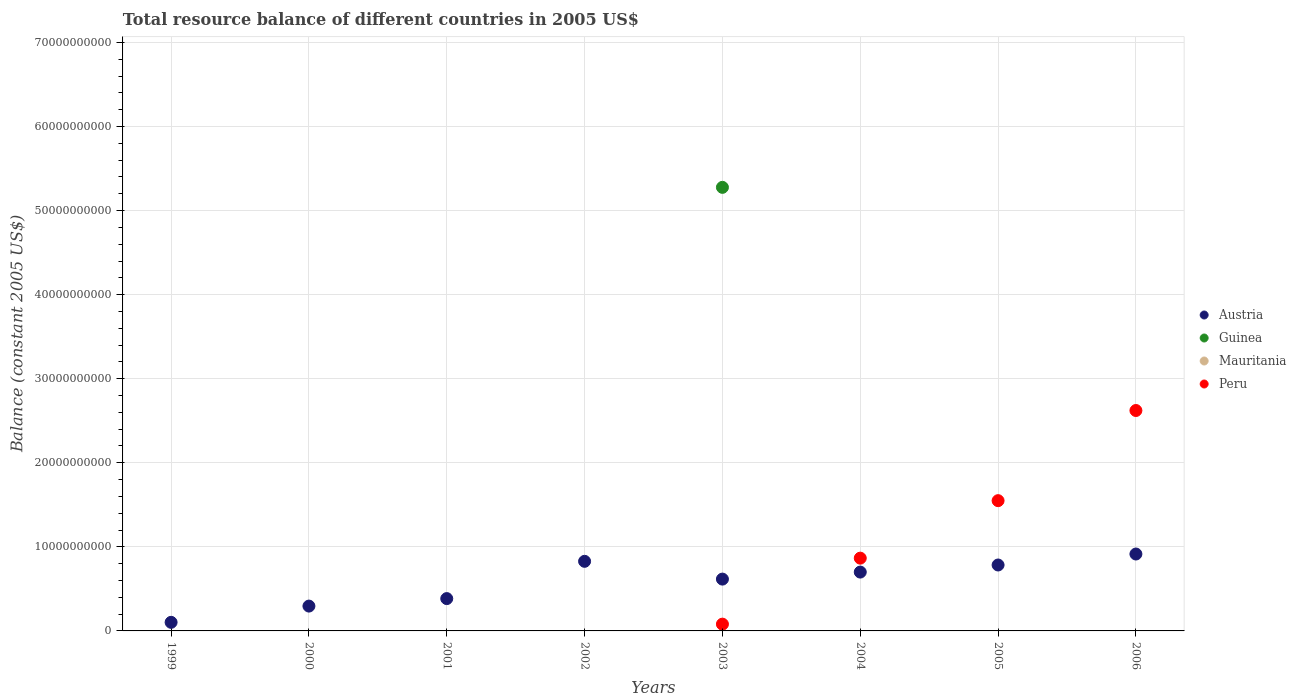What is the total resource balance in Guinea in 2001?
Offer a terse response. 0. Across all years, what is the maximum total resource balance in Austria?
Provide a succinct answer. 9.15e+09. Across all years, what is the minimum total resource balance in Peru?
Provide a succinct answer. 0. In which year was the total resource balance in Austria maximum?
Offer a terse response. 2006. What is the total total resource balance in Guinea in the graph?
Ensure brevity in your answer.  5.28e+1. What is the difference between the total resource balance in Peru in 2003 and that in 2006?
Provide a short and direct response. -2.54e+1. What is the difference between the total resource balance in Mauritania in 2003 and the total resource balance in Peru in 2001?
Your response must be concise. 0. What is the average total resource balance in Mauritania per year?
Keep it short and to the point. 0. In how many years, is the total resource balance in Mauritania greater than 34000000000 US$?
Provide a short and direct response. 0. What is the ratio of the total resource balance in Austria in 2001 to that in 2006?
Ensure brevity in your answer.  0.42. Is the total resource balance in Austria in 2001 less than that in 2002?
Keep it short and to the point. Yes. What is the difference between the highest and the second highest total resource balance in Austria?
Your response must be concise. 8.69e+08. What is the difference between the highest and the lowest total resource balance in Guinea?
Ensure brevity in your answer.  5.28e+1. Is it the case that in every year, the sum of the total resource balance in Mauritania and total resource balance in Peru  is greater than the sum of total resource balance in Guinea and total resource balance in Austria?
Provide a succinct answer. No. Is it the case that in every year, the sum of the total resource balance in Mauritania and total resource balance in Guinea  is greater than the total resource balance in Peru?
Offer a very short reply. No. Does the total resource balance in Guinea monotonically increase over the years?
Give a very brief answer. No. Is the total resource balance in Mauritania strictly less than the total resource balance in Austria over the years?
Keep it short and to the point. Yes. How many dotlines are there?
Provide a succinct answer. 3. What is the difference between two consecutive major ticks on the Y-axis?
Keep it short and to the point. 1.00e+1. Does the graph contain any zero values?
Give a very brief answer. Yes. Does the graph contain grids?
Keep it short and to the point. Yes. How many legend labels are there?
Keep it short and to the point. 4. How are the legend labels stacked?
Make the answer very short. Vertical. What is the title of the graph?
Keep it short and to the point. Total resource balance of different countries in 2005 US$. Does "Small states" appear as one of the legend labels in the graph?
Your response must be concise. No. What is the label or title of the X-axis?
Your response must be concise. Years. What is the label or title of the Y-axis?
Ensure brevity in your answer.  Balance (constant 2005 US$). What is the Balance (constant 2005 US$) in Austria in 1999?
Offer a terse response. 1.02e+09. What is the Balance (constant 2005 US$) in Guinea in 1999?
Give a very brief answer. 0. What is the Balance (constant 2005 US$) in Mauritania in 1999?
Your answer should be very brief. 0. What is the Balance (constant 2005 US$) of Austria in 2000?
Give a very brief answer. 2.95e+09. What is the Balance (constant 2005 US$) in Guinea in 2000?
Keep it short and to the point. 0. What is the Balance (constant 2005 US$) of Mauritania in 2000?
Make the answer very short. 0. What is the Balance (constant 2005 US$) of Peru in 2000?
Provide a succinct answer. 0. What is the Balance (constant 2005 US$) of Austria in 2001?
Your response must be concise. 3.85e+09. What is the Balance (constant 2005 US$) in Peru in 2001?
Provide a succinct answer. 0. What is the Balance (constant 2005 US$) in Austria in 2002?
Your response must be concise. 8.28e+09. What is the Balance (constant 2005 US$) in Mauritania in 2002?
Your answer should be very brief. 0. What is the Balance (constant 2005 US$) of Peru in 2002?
Give a very brief answer. 0. What is the Balance (constant 2005 US$) in Austria in 2003?
Provide a short and direct response. 6.16e+09. What is the Balance (constant 2005 US$) in Guinea in 2003?
Your response must be concise. 5.28e+1. What is the Balance (constant 2005 US$) of Mauritania in 2003?
Provide a short and direct response. 0. What is the Balance (constant 2005 US$) in Peru in 2003?
Make the answer very short. 8.06e+08. What is the Balance (constant 2005 US$) in Austria in 2004?
Keep it short and to the point. 7.00e+09. What is the Balance (constant 2005 US$) in Mauritania in 2004?
Provide a succinct answer. 0. What is the Balance (constant 2005 US$) of Peru in 2004?
Offer a very short reply. 8.66e+09. What is the Balance (constant 2005 US$) in Austria in 2005?
Give a very brief answer. 7.84e+09. What is the Balance (constant 2005 US$) in Guinea in 2005?
Make the answer very short. 0. What is the Balance (constant 2005 US$) in Mauritania in 2005?
Make the answer very short. 0. What is the Balance (constant 2005 US$) of Peru in 2005?
Provide a succinct answer. 1.55e+1. What is the Balance (constant 2005 US$) of Austria in 2006?
Give a very brief answer. 9.15e+09. What is the Balance (constant 2005 US$) of Mauritania in 2006?
Give a very brief answer. 0. What is the Balance (constant 2005 US$) of Peru in 2006?
Provide a short and direct response. 2.62e+1. Across all years, what is the maximum Balance (constant 2005 US$) of Austria?
Make the answer very short. 9.15e+09. Across all years, what is the maximum Balance (constant 2005 US$) in Guinea?
Ensure brevity in your answer.  5.28e+1. Across all years, what is the maximum Balance (constant 2005 US$) of Peru?
Give a very brief answer. 2.62e+1. Across all years, what is the minimum Balance (constant 2005 US$) in Austria?
Provide a short and direct response. 1.02e+09. Across all years, what is the minimum Balance (constant 2005 US$) in Guinea?
Provide a short and direct response. 0. Across all years, what is the minimum Balance (constant 2005 US$) of Peru?
Give a very brief answer. 0. What is the total Balance (constant 2005 US$) in Austria in the graph?
Keep it short and to the point. 4.63e+1. What is the total Balance (constant 2005 US$) in Guinea in the graph?
Keep it short and to the point. 5.28e+1. What is the total Balance (constant 2005 US$) of Mauritania in the graph?
Provide a succinct answer. 0. What is the total Balance (constant 2005 US$) of Peru in the graph?
Make the answer very short. 5.12e+1. What is the difference between the Balance (constant 2005 US$) of Austria in 1999 and that in 2000?
Your answer should be compact. -1.93e+09. What is the difference between the Balance (constant 2005 US$) of Austria in 1999 and that in 2001?
Offer a terse response. -2.82e+09. What is the difference between the Balance (constant 2005 US$) in Austria in 1999 and that in 2002?
Offer a very short reply. -7.26e+09. What is the difference between the Balance (constant 2005 US$) in Austria in 1999 and that in 2003?
Keep it short and to the point. -5.14e+09. What is the difference between the Balance (constant 2005 US$) in Austria in 1999 and that in 2004?
Your answer should be very brief. -5.98e+09. What is the difference between the Balance (constant 2005 US$) in Austria in 1999 and that in 2005?
Offer a terse response. -6.82e+09. What is the difference between the Balance (constant 2005 US$) in Austria in 1999 and that in 2006?
Offer a terse response. -8.13e+09. What is the difference between the Balance (constant 2005 US$) in Austria in 2000 and that in 2001?
Keep it short and to the point. -8.91e+08. What is the difference between the Balance (constant 2005 US$) of Austria in 2000 and that in 2002?
Provide a short and direct response. -5.33e+09. What is the difference between the Balance (constant 2005 US$) in Austria in 2000 and that in 2003?
Your response must be concise. -3.21e+09. What is the difference between the Balance (constant 2005 US$) of Austria in 2000 and that in 2004?
Make the answer very short. -4.05e+09. What is the difference between the Balance (constant 2005 US$) in Austria in 2000 and that in 2005?
Provide a short and direct response. -4.89e+09. What is the difference between the Balance (constant 2005 US$) of Austria in 2000 and that in 2006?
Your response must be concise. -6.19e+09. What is the difference between the Balance (constant 2005 US$) in Austria in 2001 and that in 2002?
Give a very brief answer. -4.43e+09. What is the difference between the Balance (constant 2005 US$) in Austria in 2001 and that in 2003?
Offer a very short reply. -2.32e+09. What is the difference between the Balance (constant 2005 US$) in Austria in 2001 and that in 2004?
Your answer should be very brief. -3.15e+09. What is the difference between the Balance (constant 2005 US$) in Austria in 2001 and that in 2005?
Give a very brief answer. -4.00e+09. What is the difference between the Balance (constant 2005 US$) of Austria in 2001 and that in 2006?
Your answer should be very brief. -5.30e+09. What is the difference between the Balance (constant 2005 US$) of Austria in 2002 and that in 2003?
Provide a short and direct response. 2.11e+09. What is the difference between the Balance (constant 2005 US$) of Austria in 2002 and that in 2004?
Make the answer very short. 1.28e+09. What is the difference between the Balance (constant 2005 US$) of Austria in 2002 and that in 2005?
Your response must be concise. 4.37e+08. What is the difference between the Balance (constant 2005 US$) of Austria in 2002 and that in 2006?
Provide a short and direct response. -8.69e+08. What is the difference between the Balance (constant 2005 US$) of Austria in 2003 and that in 2004?
Offer a very short reply. -8.35e+08. What is the difference between the Balance (constant 2005 US$) of Peru in 2003 and that in 2004?
Give a very brief answer. -7.85e+09. What is the difference between the Balance (constant 2005 US$) in Austria in 2003 and that in 2005?
Keep it short and to the point. -1.68e+09. What is the difference between the Balance (constant 2005 US$) of Peru in 2003 and that in 2005?
Make the answer very short. -1.47e+1. What is the difference between the Balance (constant 2005 US$) of Austria in 2003 and that in 2006?
Offer a terse response. -2.98e+09. What is the difference between the Balance (constant 2005 US$) of Peru in 2003 and that in 2006?
Keep it short and to the point. -2.54e+1. What is the difference between the Balance (constant 2005 US$) of Austria in 2004 and that in 2005?
Your answer should be compact. -8.43e+08. What is the difference between the Balance (constant 2005 US$) of Peru in 2004 and that in 2005?
Ensure brevity in your answer.  -6.84e+09. What is the difference between the Balance (constant 2005 US$) of Austria in 2004 and that in 2006?
Offer a very short reply. -2.15e+09. What is the difference between the Balance (constant 2005 US$) in Peru in 2004 and that in 2006?
Your response must be concise. -1.76e+1. What is the difference between the Balance (constant 2005 US$) in Austria in 2005 and that in 2006?
Your answer should be compact. -1.31e+09. What is the difference between the Balance (constant 2005 US$) in Peru in 2005 and that in 2006?
Provide a succinct answer. -1.07e+1. What is the difference between the Balance (constant 2005 US$) of Austria in 1999 and the Balance (constant 2005 US$) of Guinea in 2003?
Provide a succinct answer. -5.17e+1. What is the difference between the Balance (constant 2005 US$) in Austria in 1999 and the Balance (constant 2005 US$) in Peru in 2003?
Keep it short and to the point. 2.15e+08. What is the difference between the Balance (constant 2005 US$) in Austria in 1999 and the Balance (constant 2005 US$) in Peru in 2004?
Provide a short and direct response. -7.64e+09. What is the difference between the Balance (constant 2005 US$) of Austria in 1999 and the Balance (constant 2005 US$) of Peru in 2005?
Offer a very short reply. -1.45e+1. What is the difference between the Balance (constant 2005 US$) of Austria in 1999 and the Balance (constant 2005 US$) of Peru in 2006?
Provide a short and direct response. -2.52e+1. What is the difference between the Balance (constant 2005 US$) in Austria in 2000 and the Balance (constant 2005 US$) in Guinea in 2003?
Keep it short and to the point. -4.98e+1. What is the difference between the Balance (constant 2005 US$) of Austria in 2000 and the Balance (constant 2005 US$) of Peru in 2003?
Offer a very short reply. 2.15e+09. What is the difference between the Balance (constant 2005 US$) of Austria in 2000 and the Balance (constant 2005 US$) of Peru in 2004?
Give a very brief answer. -5.70e+09. What is the difference between the Balance (constant 2005 US$) in Austria in 2000 and the Balance (constant 2005 US$) in Peru in 2005?
Ensure brevity in your answer.  -1.25e+1. What is the difference between the Balance (constant 2005 US$) in Austria in 2000 and the Balance (constant 2005 US$) in Peru in 2006?
Keep it short and to the point. -2.33e+1. What is the difference between the Balance (constant 2005 US$) of Austria in 2001 and the Balance (constant 2005 US$) of Guinea in 2003?
Your answer should be very brief. -4.89e+1. What is the difference between the Balance (constant 2005 US$) in Austria in 2001 and the Balance (constant 2005 US$) in Peru in 2003?
Your response must be concise. 3.04e+09. What is the difference between the Balance (constant 2005 US$) of Austria in 2001 and the Balance (constant 2005 US$) of Peru in 2004?
Provide a succinct answer. -4.81e+09. What is the difference between the Balance (constant 2005 US$) of Austria in 2001 and the Balance (constant 2005 US$) of Peru in 2005?
Ensure brevity in your answer.  -1.17e+1. What is the difference between the Balance (constant 2005 US$) in Austria in 2001 and the Balance (constant 2005 US$) in Peru in 2006?
Ensure brevity in your answer.  -2.24e+1. What is the difference between the Balance (constant 2005 US$) in Austria in 2002 and the Balance (constant 2005 US$) in Guinea in 2003?
Make the answer very short. -4.45e+1. What is the difference between the Balance (constant 2005 US$) in Austria in 2002 and the Balance (constant 2005 US$) in Peru in 2003?
Keep it short and to the point. 7.47e+09. What is the difference between the Balance (constant 2005 US$) of Austria in 2002 and the Balance (constant 2005 US$) of Peru in 2004?
Give a very brief answer. -3.78e+08. What is the difference between the Balance (constant 2005 US$) of Austria in 2002 and the Balance (constant 2005 US$) of Peru in 2005?
Provide a succinct answer. -7.22e+09. What is the difference between the Balance (constant 2005 US$) of Austria in 2002 and the Balance (constant 2005 US$) of Peru in 2006?
Your response must be concise. -1.79e+1. What is the difference between the Balance (constant 2005 US$) of Austria in 2003 and the Balance (constant 2005 US$) of Peru in 2004?
Provide a succinct answer. -2.49e+09. What is the difference between the Balance (constant 2005 US$) in Guinea in 2003 and the Balance (constant 2005 US$) in Peru in 2004?
Provide a succinct answer. 4.41e+1. What is the difference between the Balance (constant 2005 US$) of Austria in 2003 and the Balance (constant 2005 US$) of Peru in 2005?
Ensure brevity in your answer.  -9.33e+09. What is the difference between the Balance (constant 2005 US$) of Guinea in 2003 and the Balance (constant 2005 US$) of Peru in 2005?
Your answer should be very brief. 3.73e+1. What is the difference between the Balance (constant 2005 US$) in Austria in 2003 and the Balance (constant 2005 US$) in Peru in 2006?
Ensure brevity in your answer.  -2.01e+1. What is the difference between the Balance (constant 2005 US$) of Guinea in 2003 and the Balance (constant 2005 US$) of Peru in 2006?
Keep it short and to the point. 2.65e+1. What is the difference between the Balance (constant 2005 US$) of Austria in 2004 and the Balance (constant 2005 US$) of Peru in 2005?
Your response must be concise. -8.50e+09. What is the difference between the Balance (constant 2005 US$) in Austria in 2004 and the Balance (constant 2005 US$) in Peru in 2006?
Offer a very short reply. -1.92e+1. What is the difference between the Balance (constant 2005 US$) in Austria in 2005 and the Balance (constant 2005 US$) in Peru in 2006?
Offer a very short reply. -1.84e+1. What is the average Balance (constant 2005 US$) of Austria per year?
Your response must be concise. 5.78e+09. What is the average Balance (constant 2005 US$) of Guinea per year?
Ensure brevity in your answer.  6.60e+09. What is the average Balance (constant 2005 US$) in Mauritania per year?
Your answer should be compact. 0. What is the average Balance (constant 2005 US$) of Peru per year?
Make the answer very short. 6.40e+09. In the year 2003, what is the difference between the Balance (constant 2005 US$) of Austria and Balance (constant 2005 US$) of Guinea?
Provide a short and direct response. -4.66e+1. In the year 2003, what is the difference between the Balance (constant 2005 US$) of Austria and Balance (constant 2005 US$) of Peru?
Give a very brief answer. 5.36e+09. In the year 2003, what is the difference between the Balance (constant 2005 US$) in Guinea and Balance (constant 2005 US$) in Peru?
Your answer should be compact. 5.20e+1. In the year 2004, what is the difference between the Balance (constant 2005 US$) of Austria and Balance (constant 2005 US$) of Peru?
Offer a terse response. -1.66e+09. In the year 2005, what is the difference between the Balance (constant 2005 US$) in Austria and Balance (constant 2005 US$) in Peru?
Offer a terse response. -7.65e+09. In the year 2006, what is the difference between the Balance (constant 2005 US$) in Austria and Balance (constant 2005 US$) in Peru?
Give a very brief answer. -1.71e+1. What is the ratio of the Balance (constant 2005 US$) of Austria in 1999 to that in 2000?
Give a very brief answer. 0.35. What is the ratio of the Balance (constant 2005 US$) of Austria in 1999 to that in 2001?
Offer a terse response. 0.27. What is the ratio of the Balance (constant 2005 US$) in Austria in 1999 to that in 2002?
Your answer should be compact. 0.12. What is the ratio of the Balance (constant 2005 US$) in Austria in 1999 to that in 2003?
Give a very brief answer. 0.17. What is the ratio of the Balance (constant 2005 US$) of Austria in 1999 to that in 2004?
Provide a short and direct response. 0.15. What is the ratio of the Balance (constant 2005 US$) in Austria in 1999 to that in 2005?
Offer a terse response. 0.13. What is the ratio of the Balance (constant 2005 US$) of Austria in 1999 to that in 2006?
Ensure brevity in your answer.  0.11. What is the ratio of the Balance (constant 2005 US$) of Austria in 2000 to that in 2001?
Your response must be concise. 0.77. What is the ratio of the Balance (constant 2005 US$) of Austria in 2000 to that in 2002?
Provide a succinct answer. 0.36. What is the ratio of the Balance (constant 2005 US$) of Austria in 2000 to that in 2003?
Your answer should be compact. 0.48. What is the ratio of the Balance (constant 2005 US$) in Austria in 2000 to that in 2004?
Provide a short and direct response. 0.42. What is the ratio of the Balance (constant 2005 US$) of Austria in 2000 to that in 2005?
Provide a succinct answer. 0.38. What is the ratio of the Balance (constant 2005 US$) of Austria in 2000 to that in 2006?
Ensure brevity in your answer.  0.32. What is the ratio of the Balance (constant 2005 US$) in Austria in 2001 to that in 2002?
Offer a terse response. 0.46. What is the ratio of the Balance (constant 2005 US$) in Austria in 2001 to that in 2003?
Your response must be concise. 0.62. What is the ratio of the Balance (constant 2005 US$) in Austria in 2001 to that in 2004?
Provide a short and direct response. 0.55. What is the ratio of the Balance (constant 2005 US$) of Austria in 2001 to that in 2005?
Offer a terse response. 0.49. What is the ratio of the Balance (constant 2005 US$) of Austria in 2001 to that in 2006?
Provide a short and direct response. 0.42. What is the ratio of the Balance (constant 2005 US$) in Austria in 2002 to that in 2003?
Offer a very short reply. 1.34. What is the ratio of the Balance (constant 2005 US$) in Austria in 2002 to that in 2004?
Offer a very short reply. 1.18. What is the ratio of the Balance (constant 2005 US$) in Austria in 2002 to that in 2005?
Provide a succinct answer. 1.06. What is the ratio of the Balance (constant 2005 US$) of Austria in 2002 to that in 2006?
Offer a terse response. 0.91. What is the ratio of the Balance (constant 2005 US$) in Austria in 2003 to that in 2004?
Offer a very short reply. 0.88. What is the ratio of the Balance (constant 2005 US$) of Peru in 2003 to that in 2004?
Ensure brevity in your answer.  0.09. What is the ratio of the Balance (constant 2005 US$) of Austria in 2003 to that in 2005?
Provide a succinct answer. 0.79. What is the ratio of the Balance (constant 2005 US$) in Peru in 2003 to that in 2005?
Your answer should be compact. 0.05. What is the ratio of the Balance (constant 2005 US$) in Austria in 2003 to that in 2006?
Offer a terse response. 0.67. What is the ratio of the Balance (constant 2005 US$) in Peru in 2003 to that in 2006?
Offer a very short reply. 0.03. What is the ratio of the Balance (constant 2005 US$) in Austria in 2004 to that in 2005?
Your answer should be very brief. 0.89. What is the ratio of the Balance (constant 2005 US$) in Peru in 2004 to that in 2005?
Give a very brief answer. 0.56. What is the ratio of the Balance (constant 2005 US$) of Austria in 2004 to that in 2006?
Make the answer very short. 0.77. What is the ratio of the Balance (constant 2005 US$) in Peru in 2004 to that in 2006?
Ensure brevity in your answer.  0.33. What is the ratio of the Balance (constant 2005 US$) in Austria in 2005 to that in 2006?
Make the answer very short. 0.86. What is the ratio of the Balance (constant 2005 US$) of Peru in 2005 to that in 2006?
Your answer should be very brief. 0.59. What is the difference between the highest and the second highest Balance (constant 2005 US$) of Austria?
Provide a short and direct response. 8.69e+08. What is the difference between the highest and the second highest Balance (constant 2005 US$) in Peru?
Make the answer very short. 1.07e+1. What is the difference between the highest and the lowest Balance (constant 2005 US$) of Austria?
Your answer should be compact. 8.13e+09. What is the difference between the highest and the lowest Balance (constant 2005 US$) in Guinea?
Offer a very short reply. 5.28e+1. What is the difference between the highest and the lowest Balance (constant 2005 US$) in Peru?
Provide a succinct answer. 2.62e+1. 